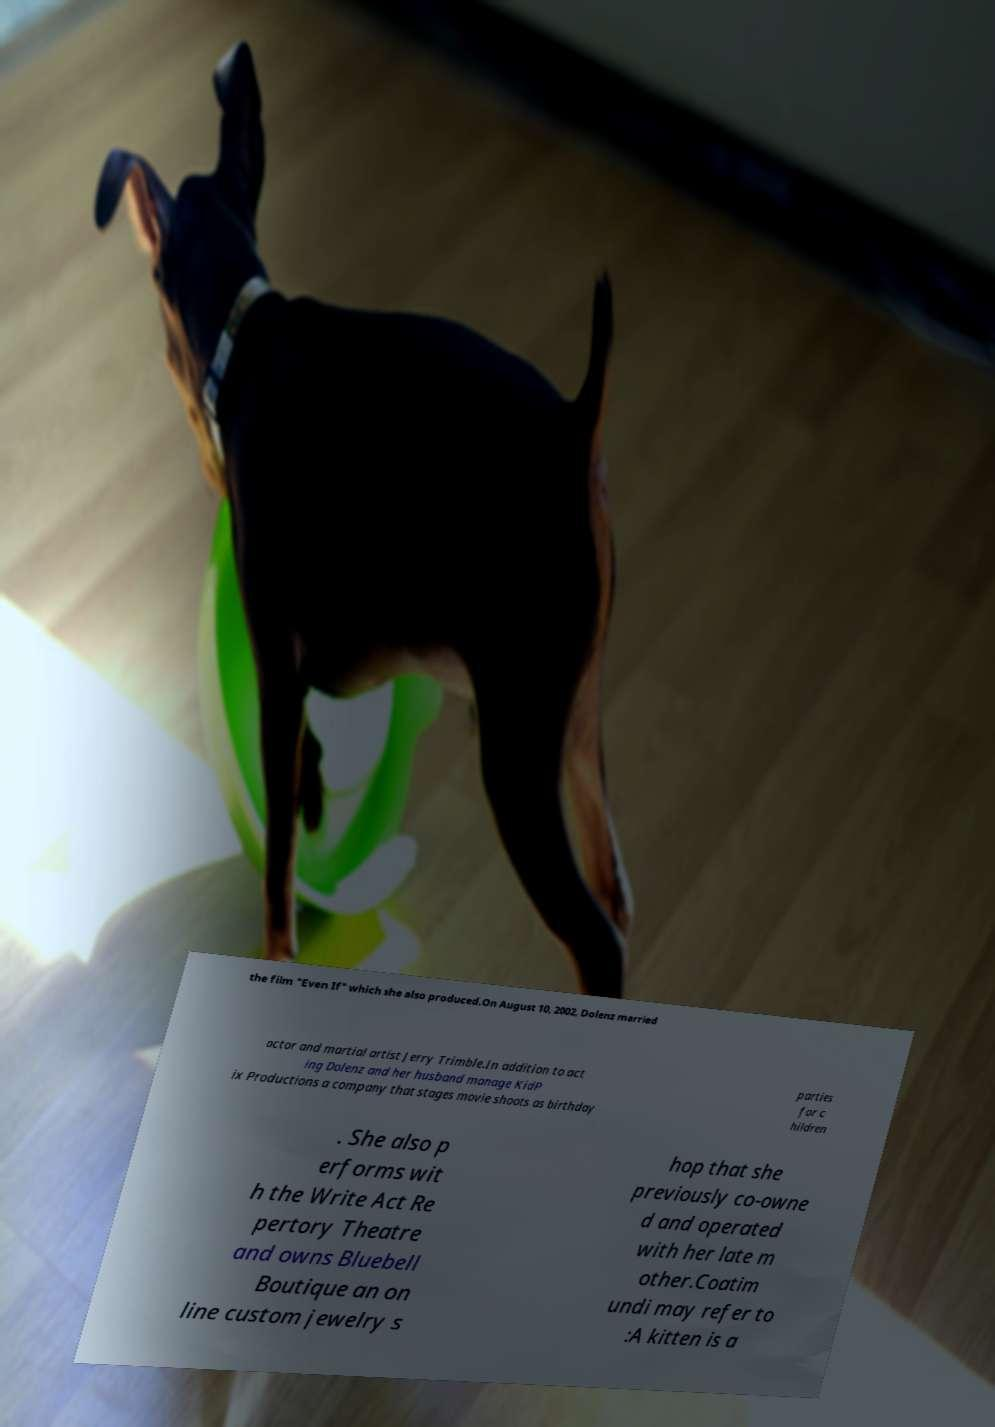Could you assist in decoding the text presented in this image and type it out clearly? the film "Even If" which she also produced.On August 10, 2002, Dolenz married actor and martial artist Jerry Trimble.In addition to act ing Dolenz and her husband manage KidP ix Productions a company that stages movie shoots as birthday parties for c hildren . She also p erforms wit h the Write Act Re pertory Theatre and owns Bluebell Boutique an on line custom jewelry s hop that she previously co-owne d and operated with her late m other.Coatim undi may refer to :A kitten is a 